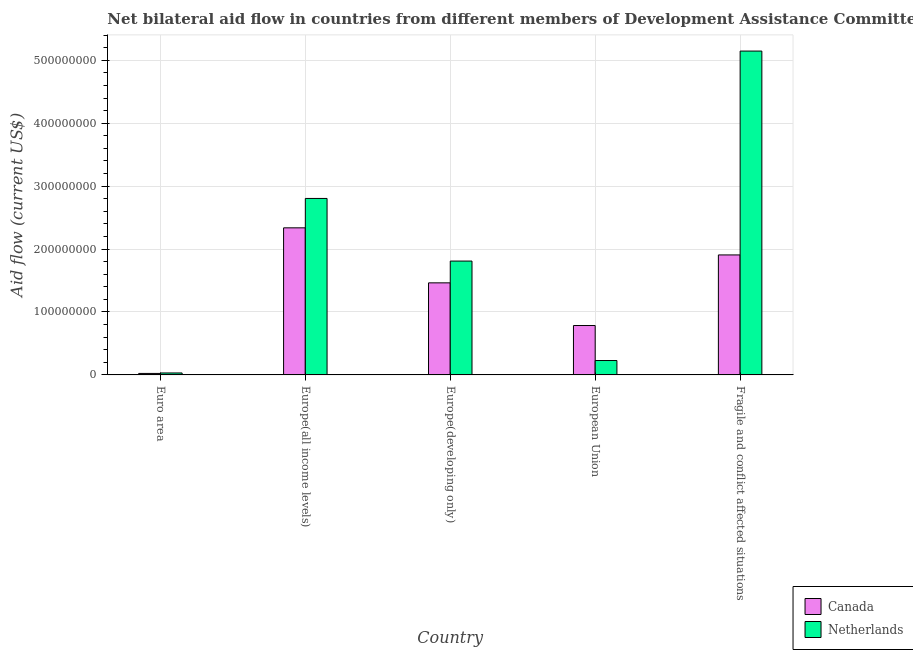Are the number of bars per tick equal to the number of legend labels?
Your answer should be very brief. Yes. Are the number of bars on each tick of the X-axis equal?
Keep it short and to the point. Yes. How many bars are there on the 5th tick from the right?
Make the answer very short. 2. What is the label of the 4th group of bars from the left?
Offer a terse response. European Union. What is the amount of aid given by netherlands in Europe(all income levels)?
Provide a short and direct response. 2.80e+08. Across all countries, what is the maximum amount of aid given by netherlands?
Provide a short and direct response. 5.15e+08. Across all countries, what is the minimum amount of aid given by netherlands?
Your answer should be compact. 3.11e+06. In which country was the amount of aid given by canada maximum?
Offer a very short reply. Europe(all income levels). What is the total amount of aid given by netherlands in the graph?
Make the answer very short. 1.00e+09. What is the difference between the amount of aid given by netherlands in Europe(developing only) and that in European Union?
Make the answer very short. 1.58e+08. What is the difference between the amount of aid given by canada in European Union and the amount of aid given by netherlands in Fragile and conflict affected situations?
Offer a very short reply. -4.36e+08. What is the average amount of aid given by netherlands per country?
Give a very brief answer. 2.00e+08. What is the difference between the amount of aid given by canada and amount of aid given by netherlands in Fragile and conflict affected situations?
Offer a terse response. -3.24e+08. What is the ratio of the amount of aid given by netherlands in Euro area to that in Europe(developing only)?
Keep it short and to the point. 0.02. Is the amount of aid given by canada in Euro area less than that in European Union?
Your answer should be compact. Yes. Is the difference between the amount of aid given by canada in Euro area and European Union greater than the difference between the amount of aid given by netherlands in Euro area and European Union?
Provide a succinct answer. No. What is the difference between the highest and the second highest amount of aid given by netherlands?
Provide a succinct answer. 2.34e+08. What is the difference between the highest and the lowest amount of aid given by netherlands?
Offer a very short reply. 5.11e+08. In how many countries, is the amount of aid given by netherlands greater than the average amount of aid given by netherlands taken over all countries?
Your answer should be very brief. 2. What does the 1st bar from the left in Euro area represents?
Give a very brief answer. Canada. What does the 1st bar from the right in Euro area represents?
Provide a succinct answer. Netherlands. How many bars are there?
Offer a very short reply. 10. How many countries are there in the graph?
Make the answer very short. 5. What is the difference between two consecutive major ticks on the Y-axis?
Offer a very short reply. 1.00e+08. Are the values on the major ticks of Y-axis written in scientific E-notation?
Give a very brief answer. No. Does the graph contain any zero values?
Provide a short and direct response. No. Where does the legend appear in the graph?
Your answer should be compact. Bottom right. How are the legend labels stacked?
Keep it short and to the point. Vertical. What is the title of the graph?
Your answer should be very brief. Net bilateral aid flow in countries from different members of Development Assistance Committee. Does "Urban Population" appear as one of the legend labels in the graph?
Make the answer very short. No. What is the label or title of the Y-axis?
Your response must be concise. Aid flow (current US$). What is the Aid flow (current US$) in Canada in Euro area?
Provide a short and direct response. 2.35e+06. What is the Aid flow (current US$) of Netherlands in Euro area?
Offer a terse response. 3.11e+06. What is the Aid flow (current US$) of Canada in Europe(all income levels)?
Make the answer very short. 2.34e+08. What is the Aid flow (current US$) of Netherlands in Europe(all income levels)?
Provide a succinct answer. 2.80e+08. What is the Aid flow (current US$) of Canada in Europe(developing only)?
Ensure brevity in your answer.  1.46e+08. What is the Aid flow (current US$) in Netherlands in Europe(developing only)?
Provide a short and direct response. 1.81e+08. What is the Aid flow (current US$) of Canada in European Union?
Make the answer very short. 7.85e+07. What is the Aid flow (current US$) in Netherlands in European Union?
Your answer should be compact. 2.29e+07. What is the Aid flow (current US$) of Canada in Fragile and conflict affected situations?
Your answer should be very brief. 1.91e+08. What is the Aid flow (current US$) in Netherlands in Fragile and conflict affected situations?
Ensure brevity in your answer.  5.15e+08. Across all countries, what is the maximum Aid flow (current US$) in Canada?
Ensure brevity in your answer.  2.34e+08. Across all countries, what is the maximum Aid flow (current US$) in Netherlands?
Provide a succinct answer. 5.15e+08. Across all countries, what is the minimum Aid flow (current US$) of Canada?
Your response must be concise. 2.35e+06. Across all countries, what is the minimum Aid flow (current US$) of Netherlands?
Offer a terse response. 3.11e+06. What is the total Aid flow (current US$) in Canada in the graph?
Provide a succinct answer. 6.51e+08. What is the total Aid flow (current US$) of Netherlands in the graph?
Provide a succinct answer. 1.00e+09. What is the difference between the Aid flow (current US$) of Canada in Euro area and that in Europe(all income levels)?
Offer a terse response. -2.31e+08. What is the difference between the Aid flow (current US$) of Netherlands in Euro area and that in Europe(all income levels)?
Your answer should be compact. -2.77e+08. What is the difference between the Aid flow (current US$) of Canada in Euro area and that in Europe(developing only)?
Your answer should be very brief. -1.44e+08. What is the difference between the Aid flow (current US$) in Netherlands in Euro area and that in Europe(developing only)?
Keep it short and to the point. -1.78e+08. What is the difference between the Aid flow (current US$) of Canada in Euro area and that in European Union?
Offer a very short reply. -7.61e+07. What is the difference between the Aid flow (current US$) of Netherlands in Euro area and that in European Union?
Give a very brief answer. -1.98e+07. What is the difference between the Aid flow (current US$) in Canada in Euro area and that in Fragile and conflict affected situations?
Keep it short and to the point. -1.88e+08. What is the difference between the Aid flow (current US$) in Netherlands in Euro area and that in Fragile and conflict affected situations?
Provide a succinct answer. -5.11e+08. What is the difference between the Aid flow (current US$) in Canada in Europe(all income levels) and that in Europe(developing only)?
Provide a succinct answer. 8.74e+07. What is the difference between the Aid flow (current US$) of Netherlands in Europe(all income levels) and that in Europe(developing only)?
Offer a terse response. 9.95e+07. What is the difference between the Aid flow (current US$) in Canada in Europe(all income levels) and that in European Union?
Provide a succinct answer. 1.55e+08. What is the difference between the Aid flow (current US$) of Netherlands in Europe(all income levels) and that in European Union?
Ensure brevity in your answer.  2.58e+08. What is the difference between the Aid flow (current US$) in Canada in Europe(all income levels) and that in Fragile and conflict affected situations?
Your answer should be compact. 4.30e+07. What is the difference between the Aid flow (current US$) in Netherlands in Europe(all income levels) and that in Fragile and conflict affected situations?
Offer a terse response. -2.34e+08. What is the difference between the Aid flow (current US$) of Canada in Europe(developing only) and that in European Union?
Make the answer very short. 6.78e+07. What is the difference between the Aid flow (current US$) of Netherlands in Europe(developing only) and that in European Union?
Provide a succinct answer. 1.58e+08. What is the difference between the Aid flow (current US$) of Canada in Europe(developing only) and that in Fragile and conflict affected situations?
Make the answer very short. -4.44e+07. What is the difference between the Aid flow (current US$) of Netherlands in Europe(developing only) and that in Fragile and conflict affected situations?
Ensure brevity in your answer.  -3.34e+08. What is the difference between the Aid flow (current US$) of Canada in European Union and that in Fragile and conflict affected situations?
Your answer should be compact. -1.12e+08. What is the difference between the Aid flow (current US$) in Netherlands in European Union and that in Fragile and conflict affected situations?
Your answer should be very brief. -4.92e+08. What is the difference between the Aid flow (current US$) in Canada in Euro area and the Aid flow (current US$) in Netherlands in Europe(all income levels)?
Keep it short and to the point. -2.78e+08. What is the difference between the Aid flow (current US$) in Canada in Euro area and the Aid flow (current US$) in Netherlands in Europe(developing only)?
Offer a terse response. -1.79e+08. What is the difference between the Aid flow (current US$) in Canada in Euro area and the Aid flow (current US$) in Netherlands in European Union?
Ensure brevity in your answer.  -2.05e+07. What is the difference between the Aid flow (current US$) in Canada in Euro area and the Aid flow (current US$) in Netherlands in Fragile and conflict affected situations?
Give a very brief answer. -5.12e+08. What is the difference between the Aid flow (current US$) of Canada in Europe(all income levels) and the Aid flow (current US$) of Netherlands in Europe(developing only)?
Give a very brief answer. 5.28e+07. What is the difference between the Aid flow (current US$) of Canada in Europe(all income levels) and the Aid flow (current US$) of Netherlands in European Union?
Your answer should be compact. 2.11e+08. What is the difference between the Aid flow (current US$) in Canada in Europe(all income levels) and the Aid flow (current US$) in Netherlands in Fragile and conflict affected situations?
Your answer should be compact. -2.81e+08. What is the difference between the Aid flow (current US$) of Canada in Europe(developing only) and the Aid flow (current US$) of Netherlands in European Union?
Your answer should be compact. 1.23e+08. What is the difference between the Aid flow (current US$) of Canada in Europe(developing only) and the Aid flow (current US$) of Netherlands in Fragile and conflict affected situations?
Make the answer very short. -3.68e+08. What is the difference between the Aid flow (current US$) in Canada in European Union and the Aid flow (current US$) in Netherlands in Fragile and conflict affected situations?
Provide a succinct answer. -4.36e+08. What is the average Aid flow (current US$) in Canada per country?
Your answer should be very brief. 1.30e+08. What is the average Aid flow (current US$) of Netherlands per country?
Give a very brief answer. 2.00e+08. What is the difference between the Aid flow (current US$) of Canada and Aid flow (current US$) of Netherlands in Euro area?
Ensure brevity in your answer.  -7.60e+05. What is the difference between the Aid flow (current US$) in Canada and Aid flow (current US$) in Netherlands in Europe(all income levels)?
Offer a terse response. -4.67e+07. What is the difference between the Aid flow (current US$) in Canada and Aid flow (current US$) in Netherlands in Europe(developing only)?
Give a very brief answer. -3.46e+07. What is the difference between the Aid flow (current US$) of Canada and Aid flow (current US$) of Netherlands in European Union?
Provide a succinct answer. 5.56e+07. What is the difference between the Aid flow (current US$) of Canada and Aid flow (current US$) of Netherlands in Fragile and conflict affected situations?
Offer a terse response. -3.24e+08. What is the ratio of the Aid flow (current US$) of Canada in Euro area to that in Europe(all income levels)?
Your response must be concise. 0.01. What is the ratio of the Aid flow (current US$) in Netherlands in Euro area to that in Europe(all income levels)?
Offer a very short reply. 0.01. What is the ratio of the Aid flow (current US$) in Canada in Euro area to that in Europe(developing only)?
Your answer should be compact. 0.02. What is the ratio of the Aid flow (current US$) of Netherlands in Euro area to that in Europe(developing only)?
Your answer should be very brief. 0.02. What is the ratio of the Aid flow (current US$) of Canada in Euro area to that in European Union?
Ensure brevity in your answer.  0.03. What is the ratio of the Aid flow (current US$) of Netherlands in Euro area to that in European Union?
Make the answer very short. 0.14. What is the ratio of the Aid flow (current US$) of Canada in Euro area to that in Fragile and conflict affected situations?
Make the answer very short. 0.01. What is the ratio of the Aid flow (current US$) in Netherlands in Euro area to that in Fragile and conflict affected situations?
Your answer should be very brief. 0.01. What is the ratio of the Aid flow (current US$) of Canada in Europe(all income levels) to that in Europe(developing only)?
Provide a short and direct response. 1.6. What is the ratio of the Aid flow (current US$) in Netherlands in Europe(all income levels) to that in Europe(developing only)?
Your response must be concise. 1.55. What is the ratio of the Aid flow (current US$) of Canada in Europe(all income levels) to that in European Union?
Your answer should be very brief. 2.98. What is the ratio of the Aid flow (current US$) in Netherlands in Europe(all income levels) to that in European Union?
Provide a succinct answer. 12.27. What is the ratio of the Aid flow (current US$) in Canada in Europe(all income levels) to that in Fragile and conflict affected situations?
Provide a short and direct response. 1.23. What is the ratio of the Aid flow (current US$) in Netherlands in Europe(all income levels) to that in Fragile and conflict affected situations?
Provide a succinct answer. 0.54. What is the ratio of the Aid flow (current US$) of Canada in Europe(developing only) to that in European Union?
Give a very brief answer. 1.86. What is the ratio of the Aid flow (current US$) in Netherlands in Europe(developing only) to that in European Union?
Keep it short and to the point. 7.91. What is the ratio of the Aid flow (current US$) of Canada in Europe(developing only) to that in Fragile and conflict affected situations?
Give a very brief answer. 0.77. What is the ratio of the Aid flow (current US$) in Netherlands in Europe(developing only) to that in Fragile and conflict affected situations?
Give a very brief answer. 0.35. What is the ratio of the Aid flow (current US$) of Canada in European Union to that in Fragile and conflict affected situations?
Give a very brief answer. 0.41. What is the ratio of the Aid flow (current US$) in Netherlands in European Union to that in Fragile and conflict affected situations?
Offer a very short reply. 0.04. What is the difference between the highest and the second highest Aid flow (current US$) in Canada?
Ensure brevity in your answer.  4.30e+07. What is the difference between the highest and the second highest Aid flow (current US$) in Netherlands?
Provide a short and direct response. 2.34e+08. What is the difference between the highest and the lowest Aid flow (current US$) of Canada?
Your response must be concise. 2.31e+08. What is the difference between the highest and the lowest Aid flow (current US$) of Netherlands?
Offer a terse response. 5.11e+08. 